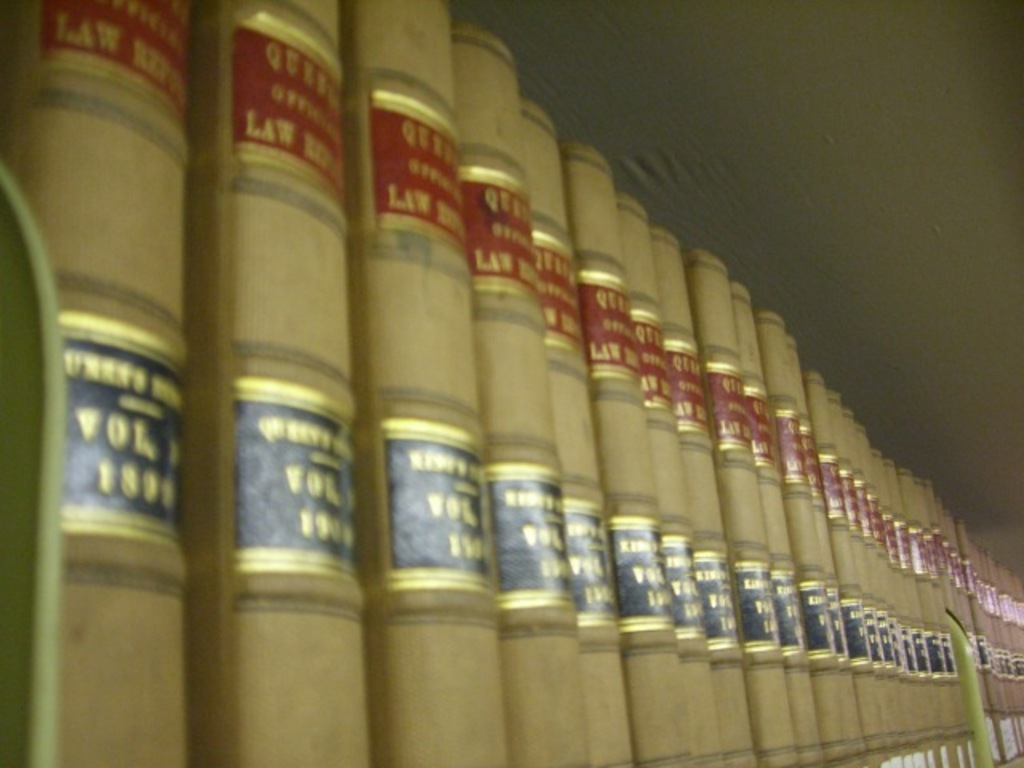What types of law are covered by the books in the image? The books primarily cover volumes of statutes and case law, specifically labeled 'QUTY' and 'LAW,' which suggests they include a range of legal documentation likely used by practitioners and students to navigate and study various aspects of the law. Can you explain why some books have different colored labels? The different colored labels on the law books typically indicate different jurisdictions or topics within law. For instance, blue might denote federal statutes, while red could signify state law or specific case law volumes, aiding in quick identification and reference. 